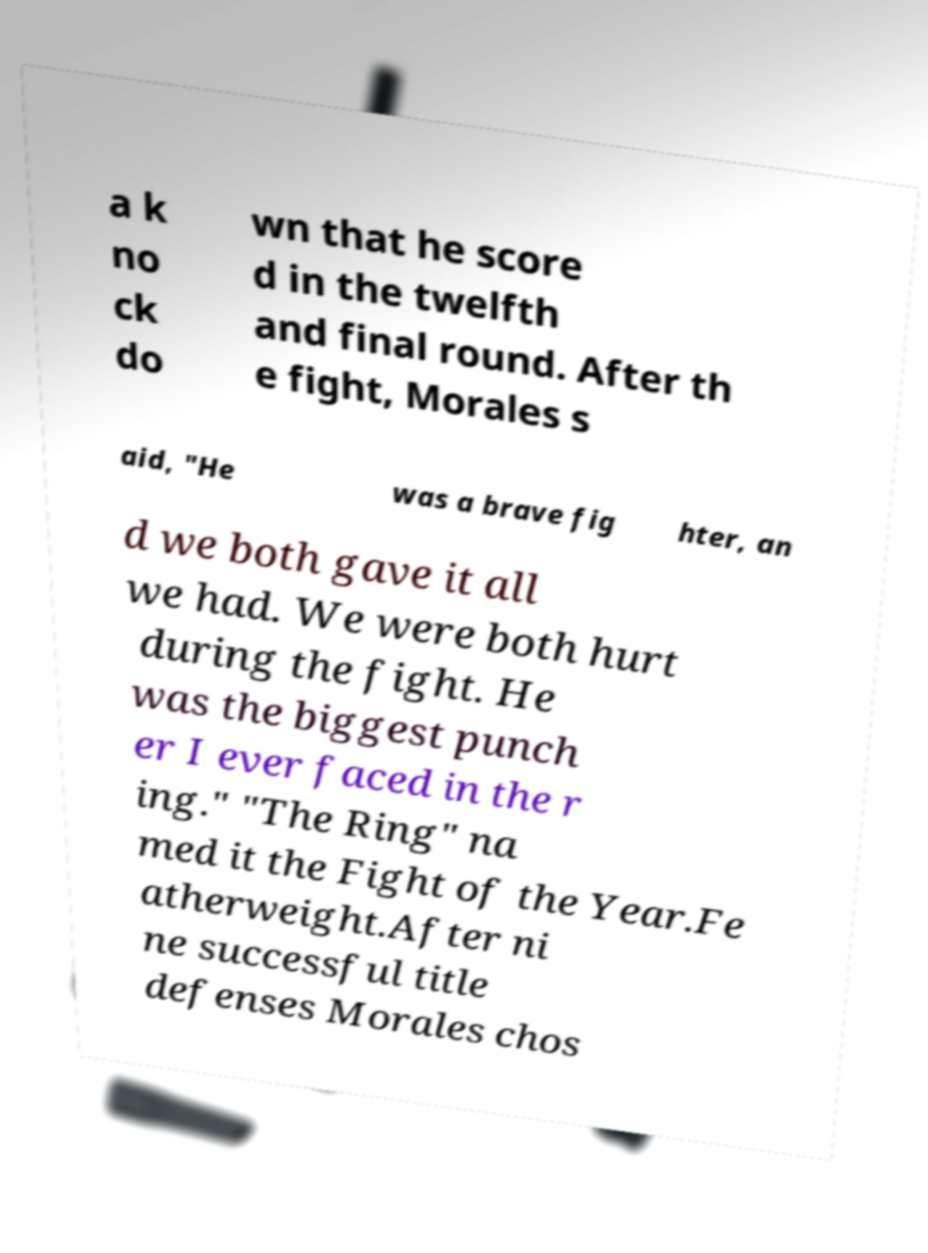There's text embedded in this image that I need extracted. Can you transcribe it verbatim? a k no ck do wn that he score d in the twelfth and final round. After th e fight, Morales s aid, "He was a brave fig hter, an d we both gave it all we had. We were both hurt during the fight. He was the biggest punch er I ever faced in the r ing." "The Ring" na med it the Fight of the Year.Fe atherweight.After ni ne successful title defenses Morales chos 